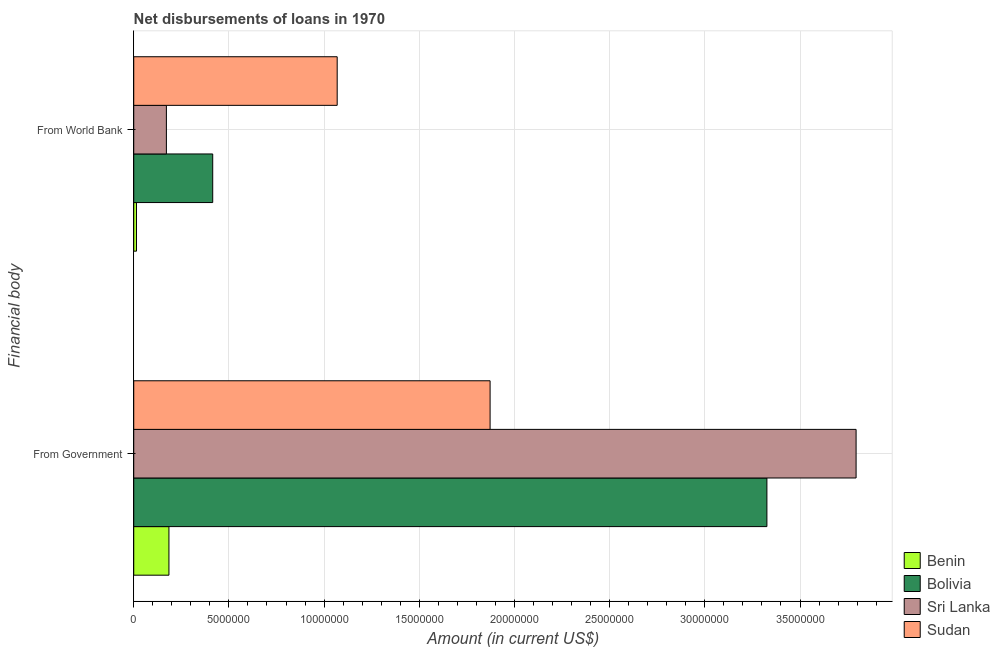How many different coloured bars are there?
Provide a short and direct response. 4. How many groups of bars are there?
Give a very brief answer. 2. Are the number of bars on each tick of the Y-axis equal?
Your answer should be very brief. Yes. How many bars are there on the 1st tick from the top?
Your response must be concise. 4. What is the label of the 1st group of bars from the top?
Your answer should be compact. From World Bank. What is the net disbursements of loan from government in Benin?
Keep it short and to the point. 1.85e+06. Across all countries, what is the maximum net disbursements of loan from world bank?
Offer a very short reply. 1.07e+07. Across all countries, what is the minimum net disbursements of loan from government?
Make the answer very short. 1.85e+06. In which country was the net disbursements of loan from world bank maximum?
Give a very brief answer. Sudan. In which country was the net disbursements of loan from government minimum?
Provide a short and direct response. Benin. What is the total net disbursements of loan from government in the graph?
Ensure brevity in your answer.  9.18e+07. What is the difference between the net disbursements of loan from government in Bolivia and that in Sudan?
Your answer should be very brief. 1.45e+07. What is the difference between the net disbursements of loan from government in Bolivia and the net disbursements of loan from world bank in Sudan?
Offer a terse response. 2.26e+07. What is the average net disbursements of loan from world bank per country?
Keep it short and to the point. 4.17e+06. What is the difference between the net disbursements of loan from world bank and net disbursements of loan from government in Benin?
Offer a very short reply. -1.70e+06. In how many countries, is the net disbursements of loan from world bank greater than 7000000 US$?
Your answer should be very brief. 1. What is the ratio of the net disbursements of loan from government in Sudan to that in Sri Lanka?
Keep it short and to the point. 0.49. Is the net disbursements of loan from world bank in Sri Lanka less than that in Bolivia?
Provide a short and direct response. Yes. What does the 1st bar from the top in From World Bank represents?
Offer a terse response. Sudan. What does the 3rd bar from the bottom in From Government represents?
Keep it short and to the point. Sri Lanka. How many bars are there?
Ensure brevity in your answer.  8. Are all the bars in the graph horizontal?
Give a very brief answer. Yes. How many countries are there in the graph?
Give a very brief answer. 4. Are the values on the major ticks of X-axis written in scientific E-notation?
Your answer should be very brief. No. Does the graph contain any zero values?
Your answer should be compact. No. How are the legend labels stacked?
Your answer should be compact. Vertical. What is the title of the graph?
Offer a very short reply. Net disbursements of loans in 1970. What is the label or title of the X-axis?
Your answer should be very brief. Amount (in current US$). What is the label or title of the Y-axis?
Give a very brief answer. Financial body. What is the Amount (in current US$) in Benin in From Government?
Give a very brief answer. 1.85e+06. What is the Amount (in current US$) of Bolivia in From Government?
Keep it short and to the point. 3.33e+07. What is the Amount (in current US$) of Sri Lanka in From Government?
Your answer should be very brief. 3.79e+07. What is the Amount (in current US$) in Sudan in From Government?
Your response must be concise. 1.87e+07. What is the Amount (in current US$) in Benin in From World Bank?
Offer a terse response. 1.45e+05. What is the Amount (in current US$) in Bolivia in From World Bank?
Offer a terse response. 4.15e+06. What is the Amount (in current US$) in Sri Lanka in From World Bank?
Make the answer very short. 1.72e+06. What is the Amount (in current US$) of Sudan in From World Bank?
Provide a succinct answer. 1.07e+07. Across all Financial body, what is the maximum Amount (in current US$) in Benin?
Give a very brief answer. 1.85e+06. Across all Financial body, what is the maximum Amount (in current US$) in Bolivia?
Your response must be concise. 3.33e+07. Across all Financial body, what is the maximum Amount (in current US$) of Sri Lanka?
Your response must be concise. 3.79e+07. Across all Financial body, what is the maximum Amount (in current US$) of Sudan?
Make the answer very short. 1.87e+07. Across all Financial body, what is the minimum Amount (in current US$) of Benin?
Provide a short and direct response. 1.45e+05. Across all Financial body, what is the minimum Amount (in current US$) in Bolivia?
Your answer should be very brief. 4.15e+06. Across all Financial body, what is the minimum Amount (in current US$) of Sri Lanka?
Your answer should be very brief. 1.72e+06. Across all Financial body, what is the minimum Amount (in current US$) of Sudan?
Keep it short and to the point. 1.07e+07. What is the total Amount (in current US$) in Benin in the graph?
Offer a very short reply. 1.99e+06. What is the total Amount (in current US$) in Bolivia in the graph?
Give a very brief answer. 3.74e+07. What is the total Amount (in current US$) in Sri Lanka in the graph?
Offer a very short reply. 3.97e+07. What is the total Amount (in current US$) of Sudan in the graph?
Your answer should be very brief. 2.94e+07. What is the difference between the Amount (in current US$) of Benin in From Government and that in From World Bank?
Keep it short and to the point. 1.70e+06. What is the difference between the Amount (in current US$) of Bolivia in From Government and that in From World Bank?
Offer a very short reply. 2.91e+07. What is the difference between the Amount (in current US$) of Sri Lanka in From Government and that in From World Bank?
Give a very brief answer. 3.62e+07. What is the difference between the Amount (in current US$) in Sudan in From Government and that in From World Bank?
Make the answer very short. 8.03e+06. What is the difference between the Amount (in current US$) of Benin in From Government and the Amount (in current US$) of Bolivia in From World Bank?
Offer a very short reply. -2.30e+06. What is the difference between the Amount (in current US$) in Benin in From Government and the Amount (in current US$) in Sri Lanka in From World Bank?
Offer a terse response. 1.34e+05. What is the difference between the Amount (in current US$) of Benin in From Government and the Amount (in current US$) of Sudan in From World Bank?
Make the answer very short. -8.84e+06. What is the difference between the Amount (in current US$) of Bolivia in From Government and the Amount (in current US$) of Sri Lanka in From World Bank?
Ensure brevity in your answer.  3.15e+07. What is the difference between the Amount (in current US$) of Bolivia in From Government and the Amount (in current US$) of Sudan in From World Bank?
Ensure brevity in your answer.  2.26e+07. What is the difference between the Amount (in current US$) in Sri Lanka in From Government and the Amount (in current US$) in Sudan in From World Bank?
Your response must be concise. 2.73e+07. What is the average Amount (in current US$) in Benin per Financial body?
Offer a very short reply. 9.97e+05. What is the average Amount (in current US$) of Bolivia per Financial body?
Offer a very short reply. 1.87e+07. What is the average Amount (in current US$) of Sri Lanka per Financial body?
Make the answer very short. 1.98e+07. What is the average Amount (in current US$) in Sudan per Financial body?
Offer a terse response. 1.47e+07. What is the difference between the Amount (in current US$) of Benin and Amount (in current US$) of Bolivia in From Government?
Give a very brief answer. -3.14e+07. What is the difference between the Amount (in current US$) in Benin and Amount (in current US$) in Sri Lanka in From Government?
Offer a terse response. -3.61e+07. What is the difference between the Amount (in current US$) of Benin and Amount (in current US$) of Sudan in From Government?
Keep it short and to the point. -1.69e+07. What is the difference between the Amount (in current US$) of Bolivia and Amount (in current US$) of Sri Lanka in From Government?
Keep it short and to the point. -4.68e+06. What is the difference between the Amount (in current US$) in Bolivia and Amount (in current US$) in Sudan in From Government?
Your answer should be very brief. 1.45e+07. What is the difference between the Amount (in current US$) in Sri Lanka and Amount (in current US$) in Sudan in From Government?
Keep it short and to the point. 1.92e+07. What is the difference between the Amount (in current US$) in Benin and Amount (in current US$) in Bolivia in From World Bank?
Your answer should be very brief. -4.00e+06. What is the difference between the Amount (in current US$) in Benin and Amount (in current US$) in Sri Lanka in From World Bank?
Provide a short and direct response. -1.57e+06. What is the difference between the Amount (in current US$) in Benin and Amount (in current US$) in Sudan in From World Bank?
Keep it short and to the point. -1.05e+07. What is the difference between the Amount (in current US$) in Bolivia and Amount (in current US$) in Sri Lanka in From World Bank?
Make the answer very short. 2.43e+06. What is the difference between the Amount (in current US$) of Bolivia and Amount (in current US$) of Sudan in From World Bank?
Provide a succinct answer. -6.54e+06. What is the difference between the Amount (in current US$) of Sri Lanka and Amount (in current US$) of Sudan in From World Bank?
Your response must be concise. -8.97e+06. What is the ratio of the Amount (in current US$) of Benin in From Government to that in From World Bank?
Provide a short and direct response. 12.75. What is the ratio of the Amount (in current US$) of Bolivia in From Government to that in From World Bank?
Your answer should be very brief. 8.02. What is the ratio of the Amount (in current US$) in Sri Lanka in From Government to that in From World Bank?
Offer a terse response. 22.13. What is the ratio of the Amount (in current US$) of Sudan in From Government to that in From World Bank?
Your answer should be very brief. 1.75. What is the difference between the highest and the second highest Amount (in current US$) in Benin?
Your answer should be very brief. 1.70e+06. What is the difference between the highest and the second highest Amount (in current US$) in Bolivia?
Offer a terse response. 2.91e+07. What is the difference between the highest and the second highest Amount (in current US$) of Sri Lanka?
Offer a very short reply. 3.62e+07. What is the difference between the highest and the second highest Amount (in current US$) in Sudan?
Make the answer very short. 8.03e+06. What is the difference between the highest and the lowest Amount (in current US$) in Benin?
Make the answer very short. 1.70e+06. What is the difference between the highest and the lowest Amount (in current US$) in Bolivia?
Provide a short and direct response. 2.91e+07. What is the difference between the highest and the lowest Amount (in current US$) in Sri Lanka?
Provide a succinct answer. 3.62e+07. What is the difference between the highest and the lowest Amount (in current US$) in Sudan?
Offer a very short reply. 8.03e+06. 